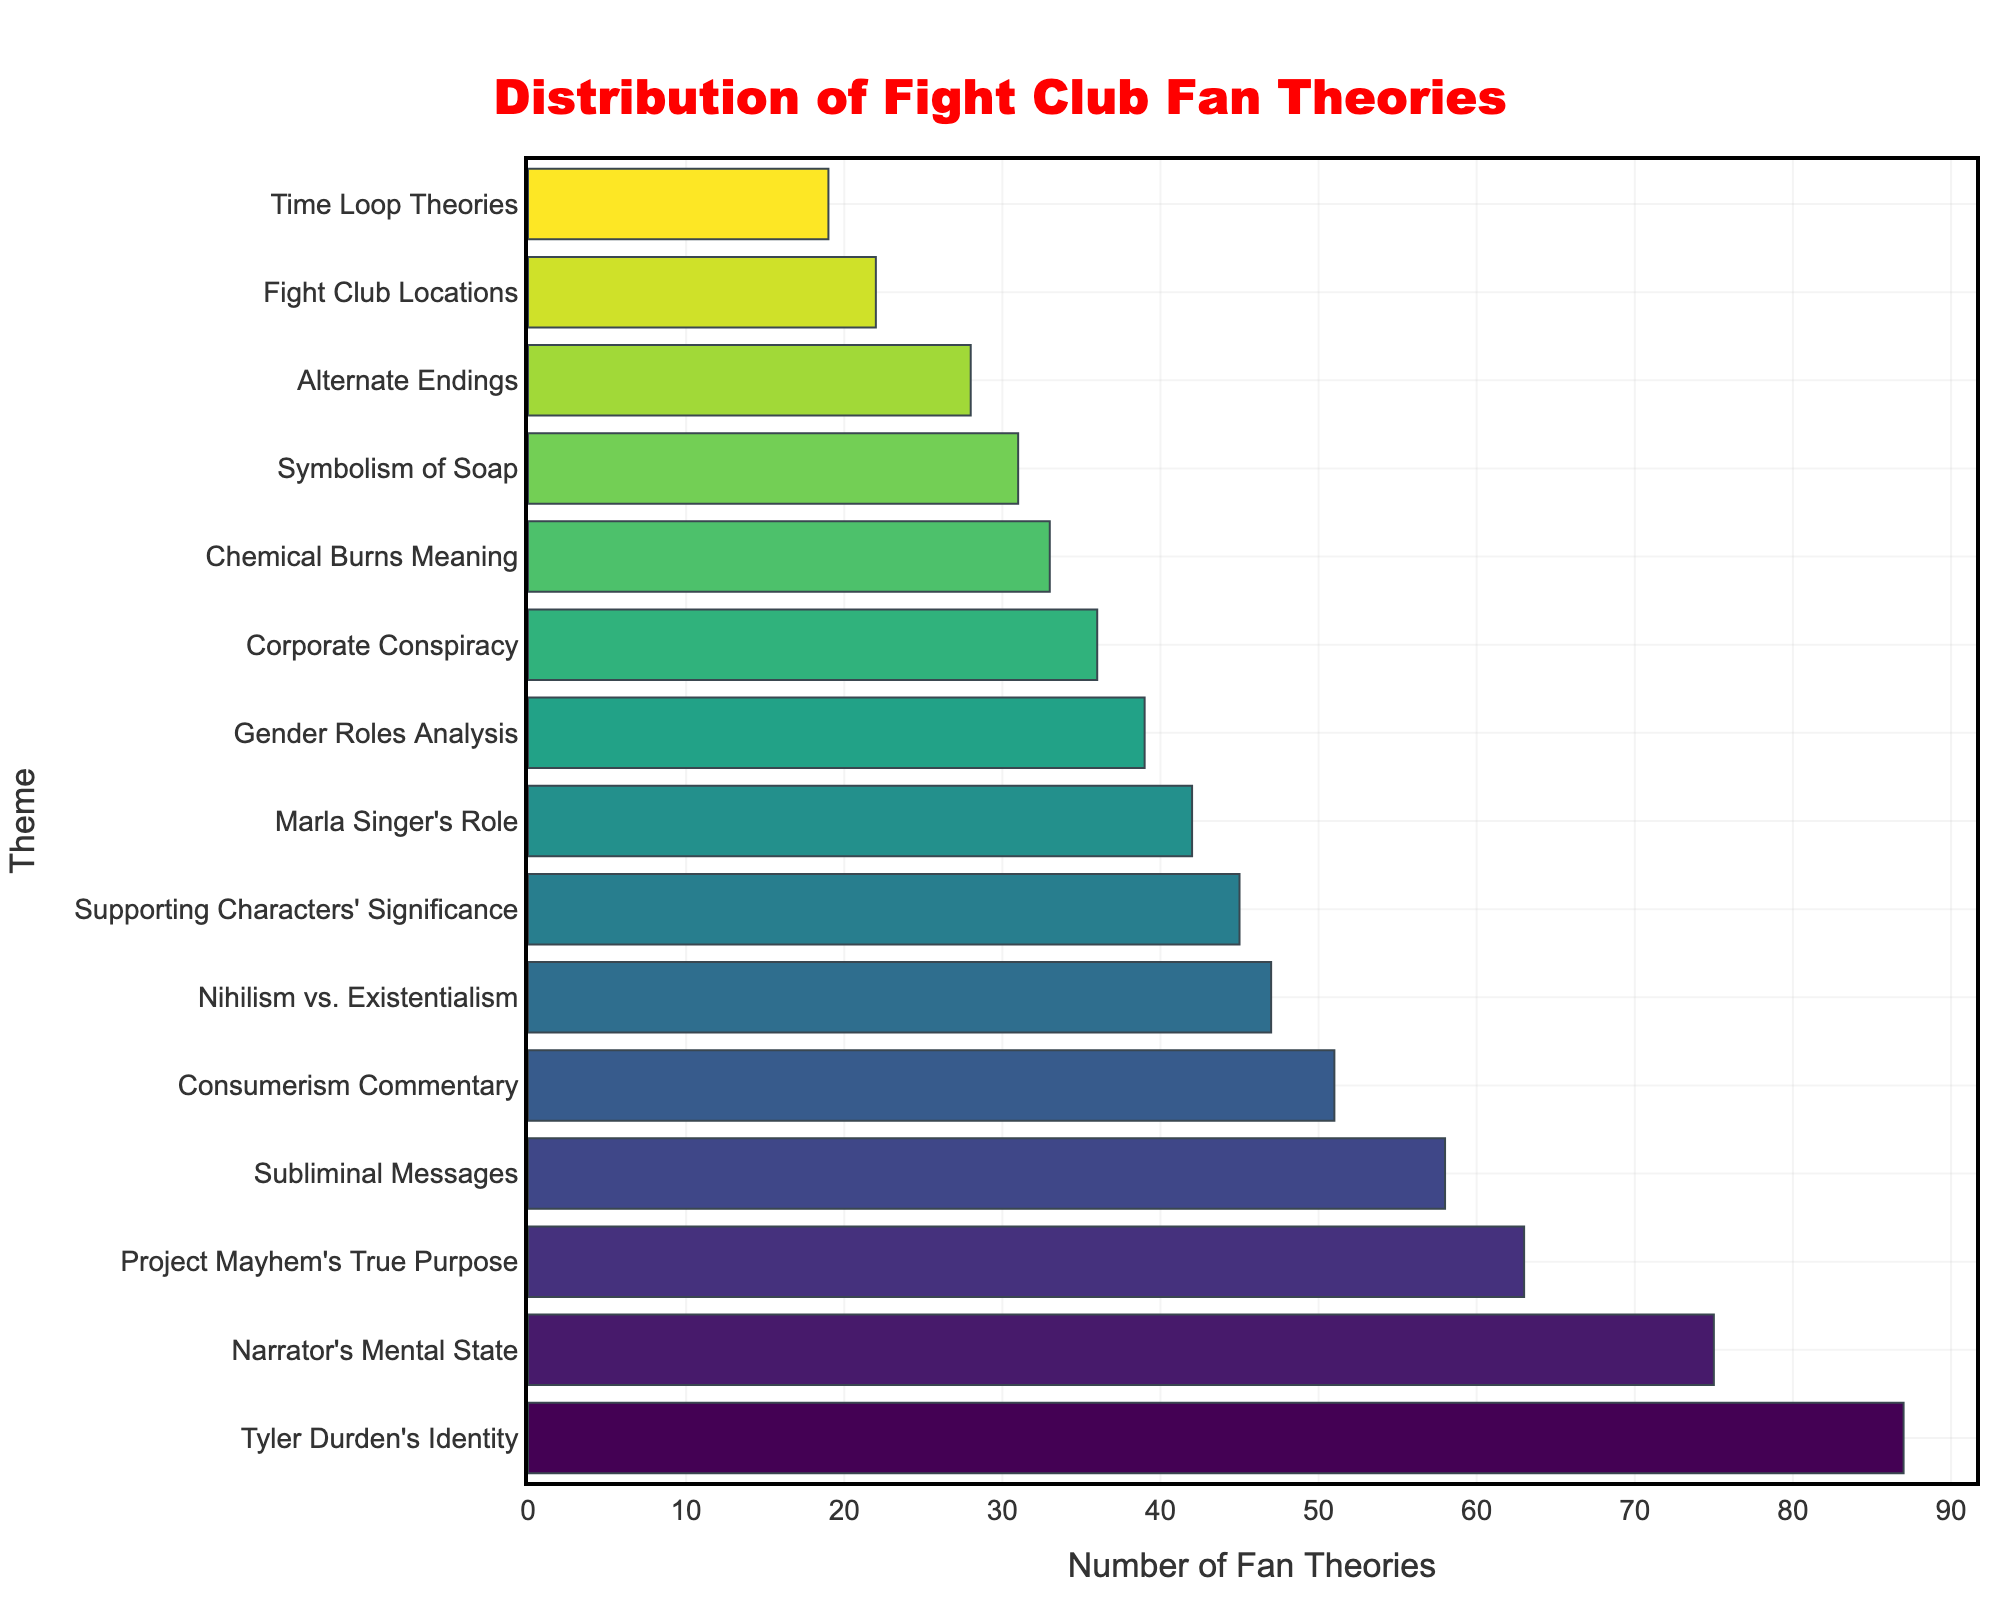What theme has the highest number of fan theories? The bar representing "Tyler Durden's Identity" is the longest, indicating it has the highest number of fan theories.
Answer: Tyler Durden's Identity Which theme has the fewest fan theories? The bar for "Time Loop Theories" is the shortest, showing it has the fewest fan theories.
Answer: Time Loop Theories How many more fan theories does "Narrator's Mental State" have compared to "Gender Roles Analysis"? "Narrator's Mental State" has 75 fan theories and "Gender Roles Analysis" has 39. The difference is 75 - 39.
Answer: 36 What is the total number of fan theories for "Project Mayhem's True Purpose", "Symbolism of Soap", and "Corporate Conspiracy"? Add the number of fan theories for each theme: 63 (Project Mayhem's True Purpose) + 31 (Symbolism of Soap) + 36 (Corporate Conspiracy) = 130.
Answer: 130 Which themes have a number of fan theories between 40 and 60? The themes within this range are "Subliminal Messages" (58), "Consumerism Commentary" (51), "Supporting Characters' Significance" (45), and "Nihilism vs. Existentialism" (47).
Answer: Subliminal Messages, Consumerism Commentary, Supporting Characters' Significance, Nihilism vs. Existentialism How many more theories does "Tyler Durden's Identity" have than "Marla Singer's Role"? "Tyler Durden's Identity" has 87 theories and "Marla Singer's Role" has 42. The difference is 87 - 42.
Answer: 45 What's the average number of theories for "Narrator's Mental State", "Fight Club Locations", and "Alternate Endings"? Add the number of theories for each theme and divide by 3: (75 + 22 + 28)/3 = 125/3.
Answer: 41.67 Which theme has slightly more fan theories: "Supporting Characters' Significance" or "Gender Roles Analysis"? "Supporting Characters' Significance" has 45 theories, while "Gender Roles Analysis" has 39. Thus, "Supporting Characters' Significance" has slightly more.
Answer: Supporting Characters' Significance How many themes have more than 50 fan theories? Count the bars that exceed the 50 mark: "Tyler Durden's Identity", "Narrator's Mental State", "Project Mayhem's True Purpose", "Subliminal Messages", and "Consumerism Commentary", which total to 5.
Answer: 5 What is the combined number of fan theories for the top three themes? Add the number of fan theories for "Tyler Durden's Identity" (87), "Narrator's Mental State" (75), and "Project Mayhem's True Purpose" (63): 87 + 75 + 63 = 225.
Answer: 225 